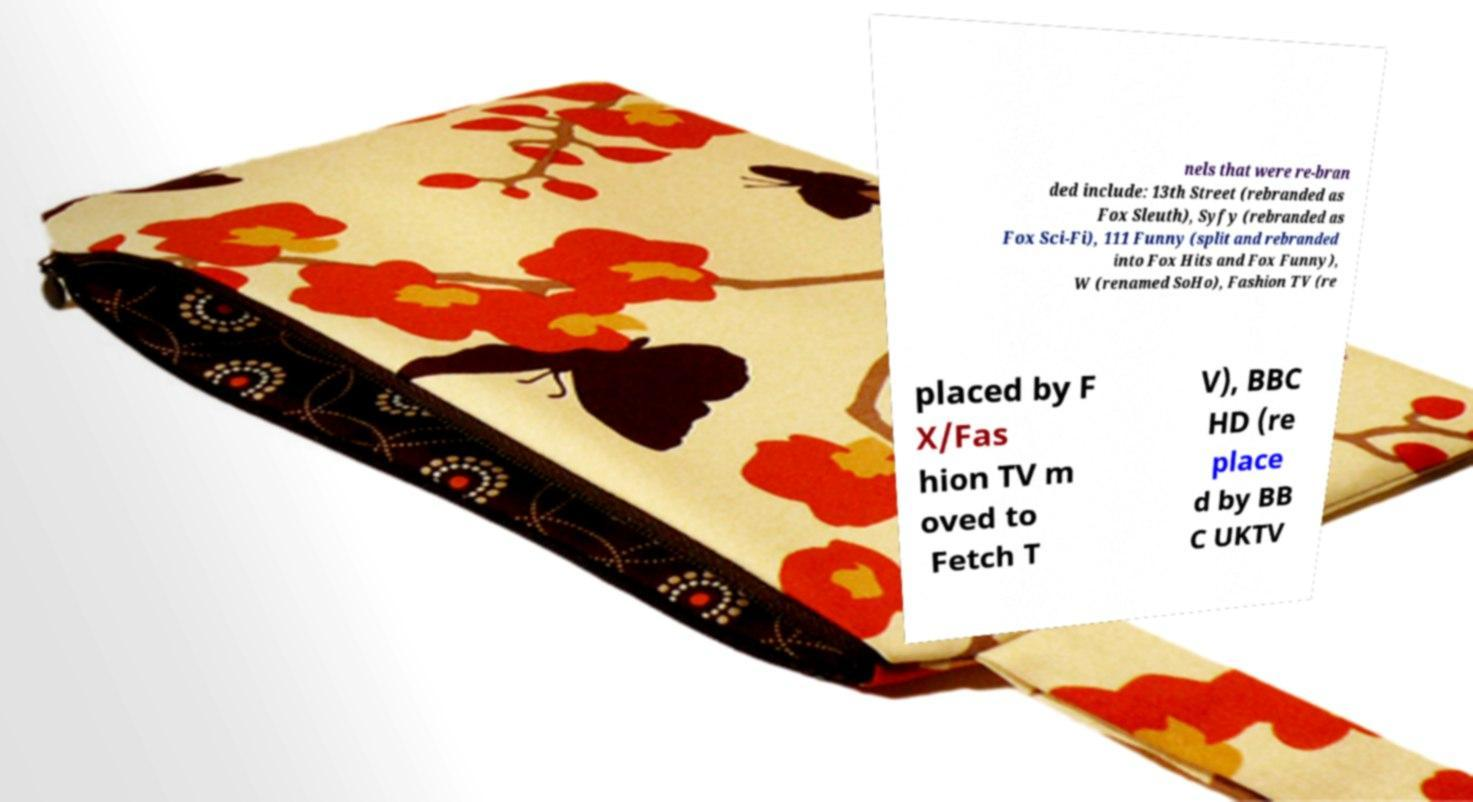Can you accurately transcribe the text from the provided image for me? nels that were re-bran ded include: 13th Street (rebranded as Fox Sleuth), Syfy (rebranded as Fox Sci-Fi), 111 Funny (split and rebranded into Fox Hits and Fox Funny), W (renamed SoHo), Fashion TV (re placed by F X/Fas hion TV m oved to Fetch T V), BBC HD (re place d by BB C UKTV 